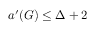Convert formula to latex. <formula><loc_0><loc_0><loc_500><loc_500>a ^ { \prime } ( G ) \leq \Delta + 2</formula> 